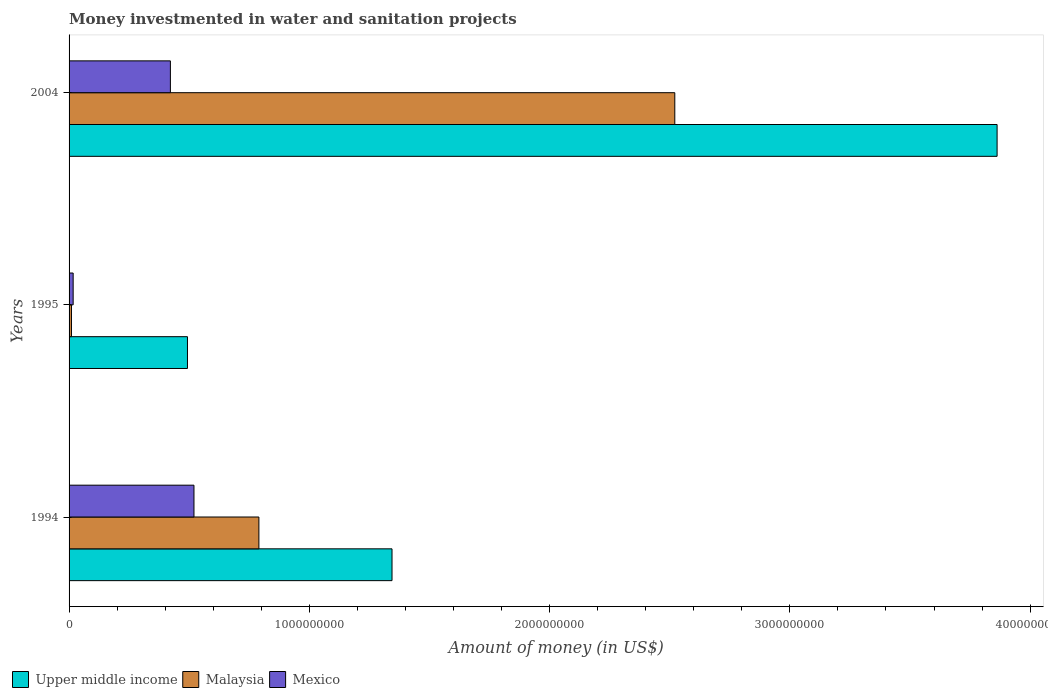How many different coloured bars are there?
Make the answer very short. 3. Are the number of bars per tick equal to the number of legend labels?
Ensure brevity in your answer.  Yes. How many bars are there on the 1st tick from the top?
Offer a very short reply. 3. In how many cases, is the number of bars for a given year not equal to the number of legend labels?
Provide a succinct answer. 0. What is the money investmented in water and sanitation projects in Malaysia in 1994?
Provide a short and direct response. 7.90e+08. Across all years, what is the maximum money investmented in water and sanitation projects in Mexico?
Your answer should be compact. 5.20e+08. Across all years, what is the minimum money investmented in water and sanitation projects in Mexico?
Provide a short and direct response. 1.70e+07. What is the total money investmented in water and sanitation projects in Upper middle income in the graph?
Give a very brief answer. 5.70e+09. What is the difference between the money investmented in water and sanitation projects in Mexico in 1994 and that in 1995?
Make the answer very short. 5.03e+08. What is the difference between the money investmented in water and sanitation projects in Malaysia in 2004 and the money investmented in water and sanitation projects in Mexico in 1994?
Make the answer very short. 2.00e+09. What is the average money investmented in water and sanitation projects in Mexico per year?
Make the answer very short. 3.20e+08. In the year 2004, what is the difference between the money investmented in water and sanitation projects in Malaysia and money investmented in water and sanitation projects in Upper middle income?
Your answer should be compact. -1.34e+09. In how many years, is the money investmented in water and sanitation projects in Mexico greater than 1400000000 US$?
Ensure brevity in your answer.  0. What is the ratio of the money investmented in water and sanitation projects in Malaysia in 1994 to that in 1995?
Your response must be concise. 79. Is the money investmented in water and sanitation projects in Upper middle income in 1994 less than that in 2004?
Give a very brief answer. Yes. What is the difference between the highest and the second highest money investmented in water and sanitation projects in Malaysia?
Keep it short and to the point. 1.73e+09. What is the difference between the highest and the lowest money investmented in water and sanitation projects in Malaysia?
Your answer should be very brief. 2.51e+09. Is the sum of the money investmented in water and sanitation projects in Upper middle income in 1994 and 1995 greater than the maximum money investmented in water and sanitation projects in Mexico across all years?
Provide a short and direct response. Yes. What does the 3rd bar from the top in 2004 represents?
Give a very brief answer. Upper middle income. What does the 2nd bar from the bottom in 2004 represents?
Offer a very short reply. Malaysia. How many bars are there?
Ensure brevity in your answer.  9. How many years are there in the graph?
Provide a short and direct response. 3. Does the graph contain grids?
Offer a terse response. No. Where does the legend appear in the graph?
Offer a terse response. Bottom left. How are the legend labels stacked?
Provide a short and direct response. Horizontal. What is the title of the graph?
Ensure brevity in your answer.  Money investmented in water and sanitation projects. What is the label or title of the X-axis?
Offer a terse response. Amount of money (in US$). What is the Amount of money (in US$) in Upper middle income in 1994?
Provide a short and direct response. 1.34e+09. What is the Amount of money (in US$) of Malaysia in 1994?
Your answer should be compact. 7.90e+08. What is the Amount of money (in US$) in Mexico in 1994?
Offer a very short reply. 5.20e+08. What is the Amount of money (in US$) of Upper middle income in 1995?
Offer a terse response. 4.93e+08. What is the Amount of money (in US$) of Mexico in 1995?
Provide a succinct answer. 1.70e+07. What is the Amount of money (in US$) of Upper middle income in 2004?
Your response must be concise. 3.86e+09. What is the Amount of money (in US$) of Malaysia in 2004?
Offer a very short reply. 2.52e+09. What is the Amount of money (in US$) of Mexico in 2004?
Make the answer very short. 4.22e+08. Across all years, what is the maximum Amount of money (in US$) of Upper middle income?
Offer a terse response. 3.86e+09. Across all years, what is the maximum Amount of money (in US$) of Malaysia?
Offer a terse response. 2.52e+09. Across all years, what is the maximum Amount of money (in US$) in Mexico?
Provide a succinct answer. 5.20e+08. Across all years, what is the minimum Amount of money (in US$) of Upper middle income?
Give a very brief answer. 4.93e+08. Across all years, what is the minimum Amount of money (in US$) of Malaysia?
Your answer should be compact. 1.00e+07. Across all years, what is the minimum Amount of money (in US$) in Mexico?
Provide a short and direct response. 1.70e+07. What is the total Amount of money (in US$) in Upper middle income in the graph?
Your answer should be very brief. 5.70e+09. What is the total Amount of money (in US$) of Malaysia in the graph?
Offer a terse response. 3.32e+09. What is the total Amount of money (in US$) of Mexico in the graph?
Make the answer very short. 9.58e+08. What is the difference between the Amount of money (in US$) in Upper middle income in 1994 and that in 1995?
Your response must be concise. 8.51e+08. What is the difference between the Amount of money (in US$) of Malaysia in 1994 and that in 1995?
Your response must be concise. 7.80e+08. What is the difference between the Amount of money (in US$) of Mexico in 1994 and that in 1995?
Your response must be concise. 5.03e+08. What is the difference between the Amount of money (in US$) in Upper middle income in 1994 and that in 2004?
Offer a very short reply. -2.52e+09. What is the difference between the Amount of money (in US$) in Malaysia in 1994 and that in 2004?
Your answer should be compact. -1.73e+09. What is the difference between the Amount of money (in US$) in Mexico in 1994 and that in 2004?
Offer a terse response. 9.81e+07. What is the difference between the Amount of money (in US$) in Upper middle income in 1995 and that in 2004?
Your response must be concise. -3.37e+09. What is the difference between the Amount of money (in US$) of Malaysia in 1995 and that in 2004?
Your response must be concise. -2.51e+09. What is the difference between the Amount of money (in US$) in Mexico in 1995 and that in 2004?
Your answer should be very brief. -4.05e+08. What is the difference between the Amount of money (in US$) in Upper middle income in 1994 and the Amount of money (in US$) in Malaysia in 1995?
Ensure brevity in your answer.  1.33e+09. What is the difference between the Amount of money (in US$) in Upper middle income in 1994 and the Amount of money (in US$) in Mexico in 1995?
Offer a terse response. 1.33e+09. What is the difference between the Amount of money (in US$) in Malaysia in 1994 and the Amount of money (in US$) in Mexico in 1995?
Keep it short and to the point. 7.73e+08. What is the difference between the Amount of money (in US$) in Upper middle income in 1994 and the Amount of money (in US$) in Malaysia in 2004?
Ensure brevity in your answer.  -1.18e+09. What is the difference between the Amount of money (in US$) of Upper middle income in 1994 and the Amount of money (in US$) of Mexico in 2004?
Your response must be concise. 9.22e+08. What is the difference between the Amount of money (in US$) of Malaysia in 1994 and the Amount of money (in US$) of Mexico in 2004?
Ensure brevity in your answer.  3.68e+08. What is the difference between the Amount of money (in US$) of Upper middle income in 1995 and the Amount of money (in US$) of Malaysia in 2004?
Give a very brief answer. -2.03e+09. What is the difference between the Amount of money (in US$) of Upper middle income in 1995 and the Amount of money (in US$) of Mexico in 2004?
Provide a succinct answer. 7.11e+07. What is the difference between the Amount of money (in US$) in Malaysia in 1995 and the Amount of money (in US$) in Mexico in 2004?
Give a very brief answer. -4.12e+08. What is the average Amount of money (in US$) in Upper middle income per year?
Offer a very short reply. 1.90e+09. What is the average Amount of money (in US$) of Malaysia per year?
Your response must be concise. 1.11e+09. What is the average Amount of money (in US$) in Mexico per year?
Your answer should be compact. 3.20e+08. In the year 1994, what is the difference between the Amount of money (in US$) of Upper middle income and Amount of money (in US$) of Malaysia?
Offer a very short reply. 5.54e+08. In the year 1994, what is the difference between the Amount of money (in US$) of Upper middle income and Amount of money (in US$) of Mexico?
Make the answer very short. 8.24e+08. In the year 1994, what is the difference between the Amount of money (in US$) in Malaysia and Amount of money (in US$) in Mexico?
Ensure brevity in your answer.  2.70e+08. In the year 1995, what is the difference between the Amount of money (in US$) of Upper middle income and Amount of money (in US$) of Malaysia?
Make the answer very short. 4.83e+08. In the year 1995, what is the difference between the Amount of money (in US$) in Upper middle income and Amount of money (in US$) in Mexico?
Ensure brevity in your answer.  4.76e+08. In the year 1995, what is the difference between the Amount of money (in US$) in Malaysia and Amount of money (in US$) in Mexico?
Your answer should be very brief. -7.00e+06. In the year 2004, what is the difference between the Amount of money (in US$) in Upper middle income and Amount of money (in US$) in Malaysia?
Ensure brevity in your answer.  1.34e+09. In the year 2004, what is the difference between the Amount of money (in US$) of Upper middle income and Amount of money (in US$) of Mexico?
Keep it short and to the point. 3.44e+09. In the year 2004, what is the difference between the Amount of money (in US$) of Malaysia and Amount of money (in US$) of Mexico?
Provide a short and direct response. 2.10e+09. What is the ratio of the Amount of money (in US$) of Upper middle income in 1994 to that in 1995?
Your answer should be compact. 2.73. What is the ratio of the Amount of money (in US$) in Malaysia in 1994 to that in 1995?
Your answer should be compact. 79. What is the ratio of the Amount of money (in US$) of Mexico in 1994 to that in 1995?
Provide a succinct answer. 30.58. What is the ratio of the Amount of money (in US$) in Upper middle income in 1994 to that in 2004?
Your answer should be very brief. 0.35. What is the ratio of the Amount of money (in US$) of Malaysia in 1994 to that in 2004?
Offer a terse response. 0.31. What is the ratio of the Amount of money (in US$) in Mexico in 1994 to that in 2004?
Keep it short and to the point. 1.23. What is the ratio of the Amount of money (in US$) in Upper middle income in 1995 to that in 2004?
Give a very brief answer. 0.13. What is the ratio of the Amount of money (in US$) in Malaysia in 1995 to that in 2004?
Make the answer very short. 0. What is the ratio of the Amount of money (in US$) of Mexico in 1995 to that in 2004?
Keep it short and to the point. 0.04. What is the difference between the highest and the second highest Amount of money (in US$) in Upper middle income?
Your answer should be compact. 2.52e+09. What is the difference between the highest and the second highest Amount of money (in US$) in Malaysia?
Provide a short and direct response. 1.73e+09. What is the difference between the highest and the second highest Amount of money (in US$) in Mexico?
Your answer should be very brief. 9.81e+07. What is the difference between the highest and the lowest Amount of money (in US$) of Upper middle income?
Make the answer very short. 3.37e+09. What is the difference between the highest and the lowest Amount of money (in US$) in Malaysia?
Your answer should be very brief. 2.51e+09. What is the difference between the highest and the lowest Amount of money (in US$) of Mexico?
Keep it short and to the point. 5.03e+08. 